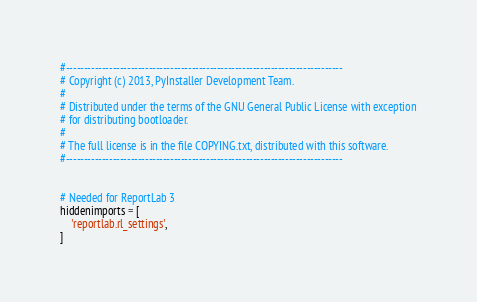Convert code to text. <code><loc_0><loc_0><loc_500><loc_500><_Python_>#-----------------------------------------------------------------------------
# Copyright (c) 2013, PyInstaller Development Team.
#
# Distributed under the terms of the GNU General Public License with exception
# for distributing bootloader.
#
# The full license is in the file COPYING.txt, distributed with this software.
#-----------------------------------------------------------------------------


# Needed for ReportLab 3
hiddenimports = [
    'reportlab.rl_settings',
]
</code> 